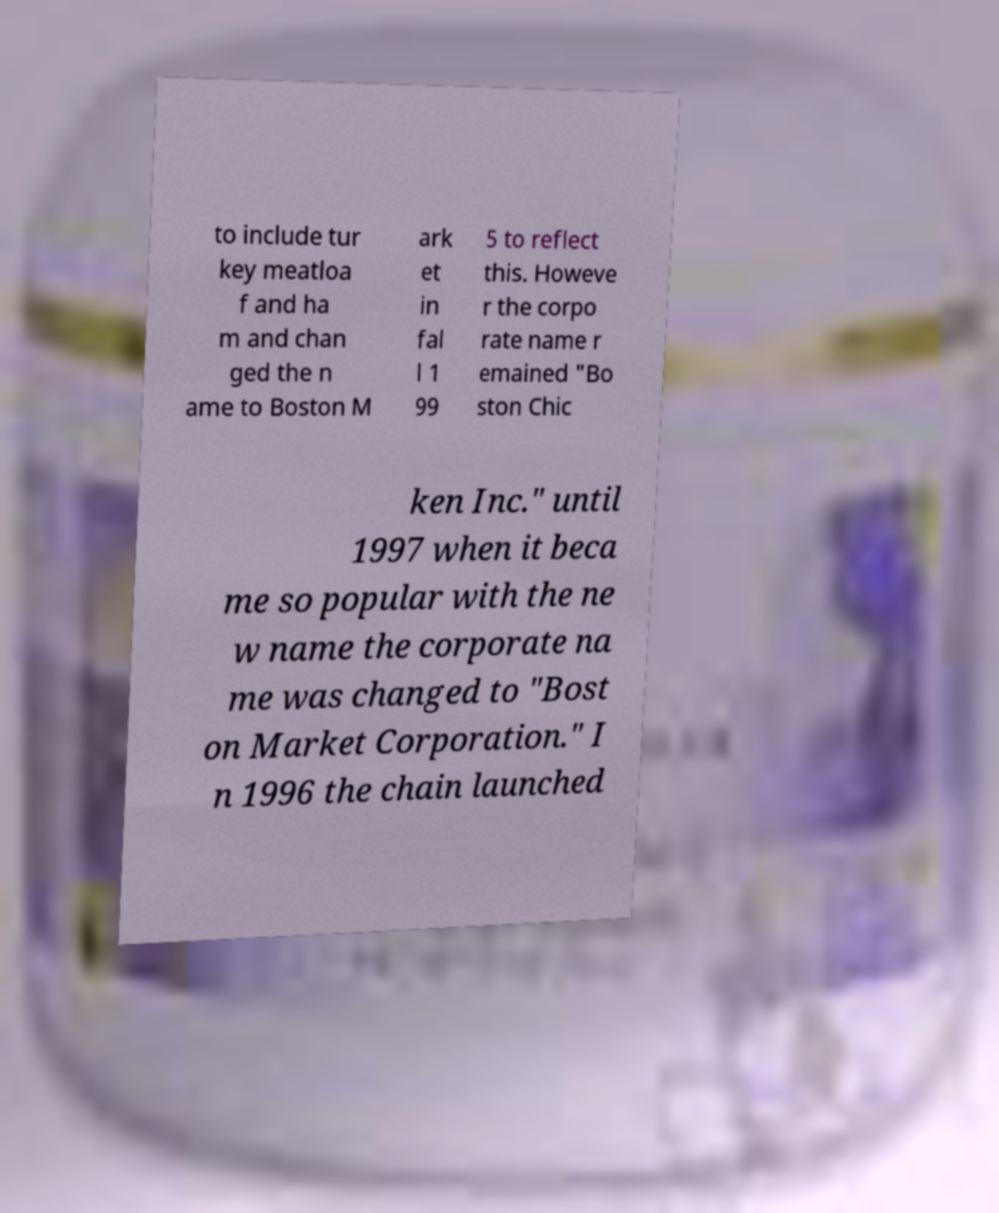Can you accurately transcribe the text from the provided image for me? to include tur key meatloa f and ha m and chan ged the n ame to Boston M ark et in fal l 1 99 5 to reflect this. Howeve r the corpo rate name r emained "Bo ston Chic ken Inc." until 1997 when it beca me so popular with the ne w name the corporate na me was changed to "Bost on Market Corporation." I n 1996 the chain launched 